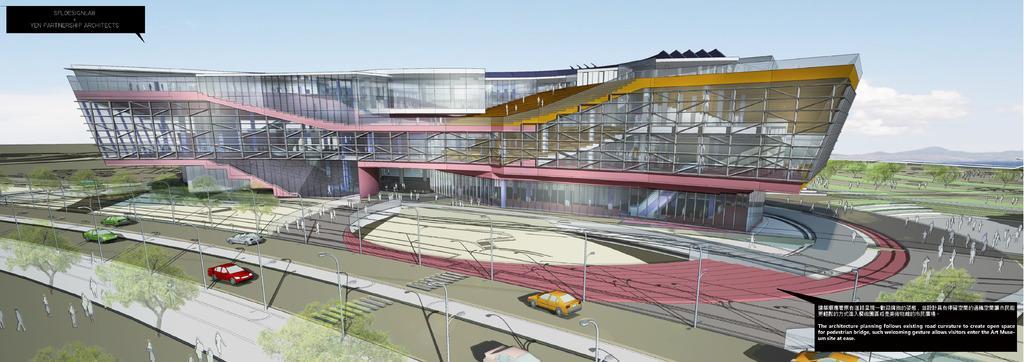Please provide a concise description of this image. This is an animated picture. In this picture we can see a building, electric light poles, vehicles, trees, road, some persons. At the top of the image we can see the sky. On the right side of the image we can see the mountains. In the bottom right corner we can see the text. In the top left corner we can see the text. 